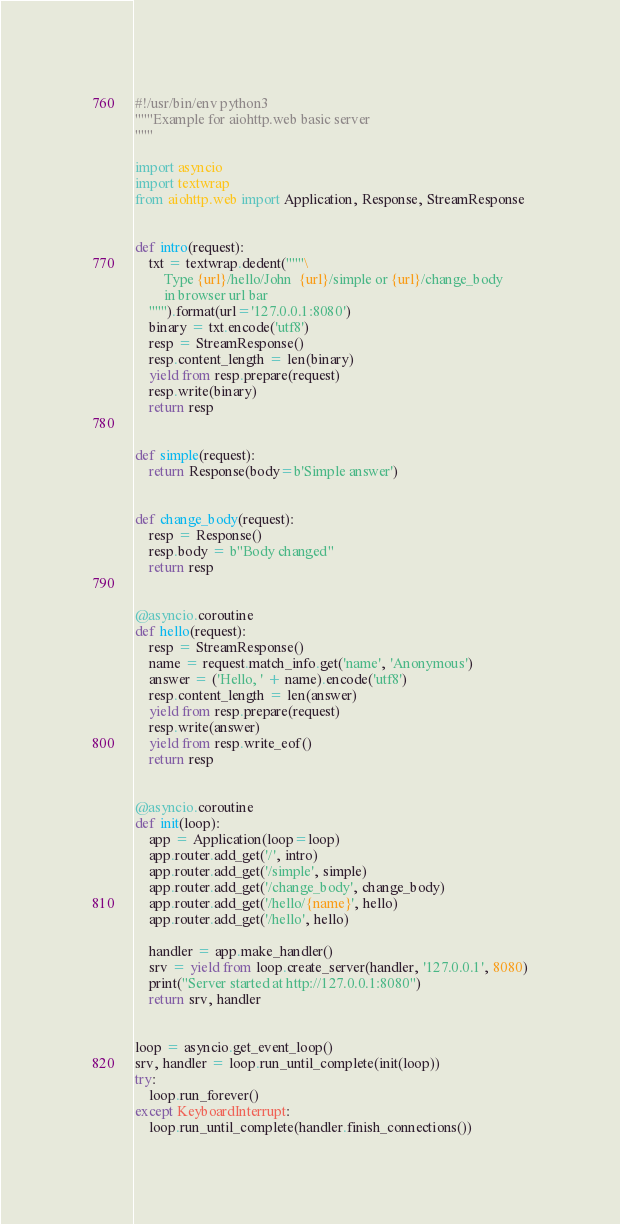Convert code to text. <code><loc_0><loc_0><loc_500><loc_500><_Python_>#!/usr/bin/env python3
"""Example for aiohttp.web basic server
"""

import asyncio
import textwrap
from aiohttp.web import Application, Response, StreamResponse


def intro(request):
    txt = textwrap.dedent("""\
        Type {url}/hello/John  {url}/simple or {url}/change_body
        in browser url bar
    """).format(url='127.0.0.1:8080')
    binary = txt.encode('utf8')
    resp = StreamResponse()
    resp.content_length = len(binary)
    yield from resp.prepare(request)
    resp.write(binary)
    return resp


def simple(request):
    return Response(body=b'Simple answer')


def change_body(request):
    resp = Response()
    resp.body = b"Body changed"
    return resp


@asyncio.coroutine
def hello(request):
    resp = StreamResponse()
    name = request.match_info.get('name', 'Anonymous')
    answer = ('Hello, ' + name).encode('utf8')
    resp.content_length = len(answer)
    yield from resp.prepare(request)
    resp.write(answer)
    yield from resp.write_eof()
    return resp


@asyncio.coroutine
def init(loop):
    app = Application(loop=loop)
    app.router.add_get('/', intro)
    app.router.add_get('/simple', simple)
    app.router.add_get('/change_body', change_body)
    app.router.add_get('/hello/{name}', hello)
    app.router.add_get('/hello', hello)

    handler = app.make_handler()
    srv = yield from loop.create_server(handler, '127.0.0.1', 8080)
    print("Server started at http://127.0.0.1:8080")
    return srv, handler


loop = asyncio.get_event_loop()
srv, handler = loop.run_until_complete(init(loop))
try:
    loop.run_forever()
except KeyboardInterrupt:
    loop.run_until_complete(handler.finish_connections())
</code> 